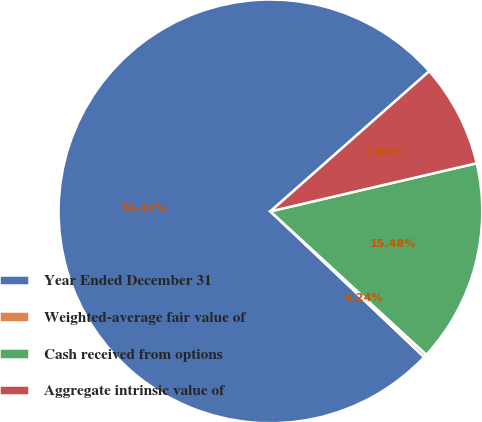Convert chart. <chart><loc_0><loc_0><loc_500><loc_500><pie_chart><fcel>Year Ended December 31<fcel>Weighted-average fair value of<fcel>Cash received from options<fcel>Aggregate intrinsic value of<nl><fcel>76.42%<fcel>0.24%<fcel>15.48%<fcel>7.86%<nl></chart> 